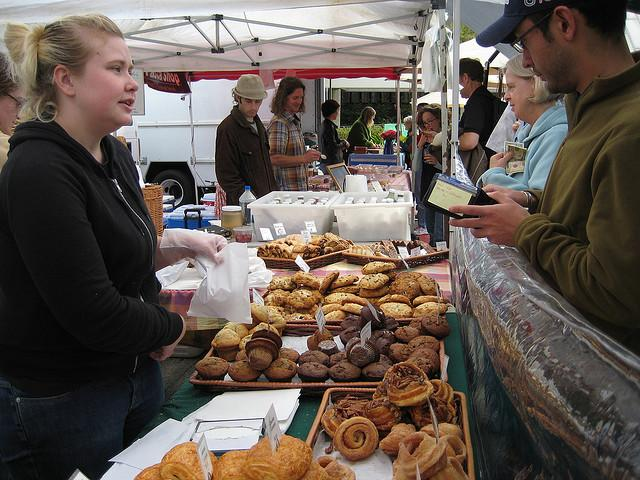Why is the woman on the left standing behind the table of pastries?

Choices:
A) she's buying
B) she's looking
C) she's selling
D) she's baking she's selling 